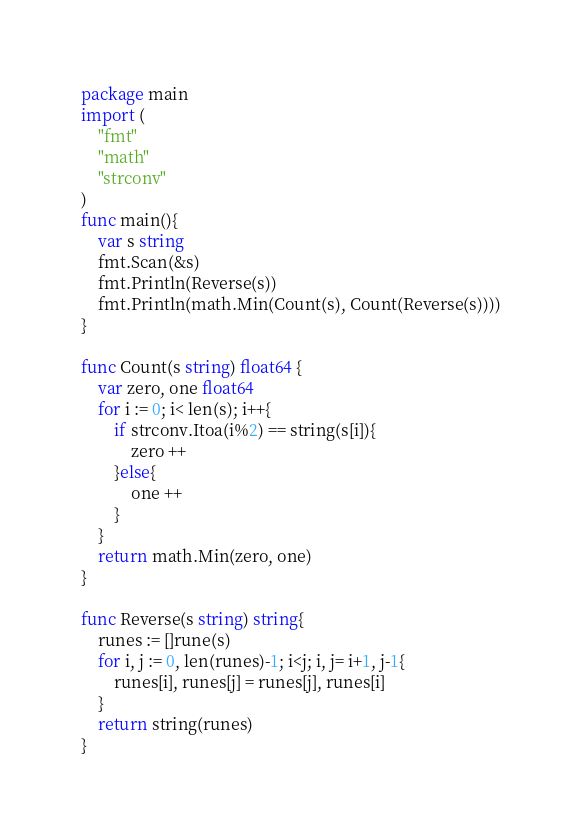Convert code to text. <code><loc_0><loc_0><loc_500><loc_500><_Go_>package main
import (
    "fmt"
    "math"
    "strconv"
)
func main(){
    var s string
    fmt.Scan(&s)
    fmt.Println(Reverse(s))
    fmt.Println(math.Min(Count(s), Count(Reverse(s))))
}

func Count(s string) float64 {
    var zero, one float64
    for i := 0; i< len(s); i++{
        if strconv.Itoa(i%2) == string(s[i]){
            zero ++
        }else{
            one ++
        }
    }
    return math.Min(zero, one)
}

func Reverse(s string) string{
    runes := []rune(s)
    for i, j := 0, len(runes)-1; i<j; i, j= i+1, j-1{
        runes[i], runes[j] = runes[j], runes[i]
    }
    return string(runes)
}</code> 